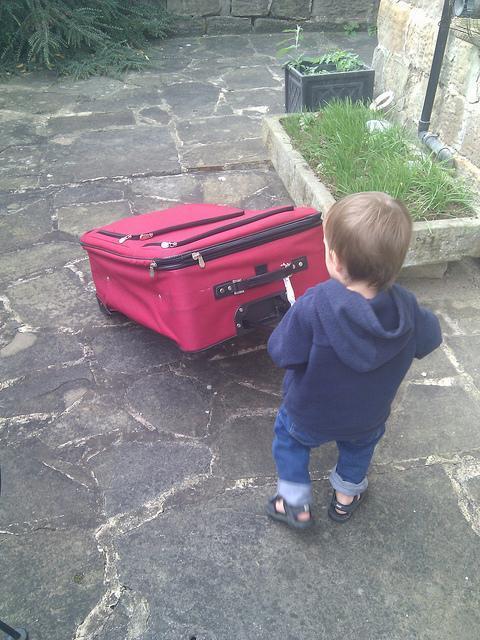How many donuts are on the tray?
Give a very brief answer. 0. 